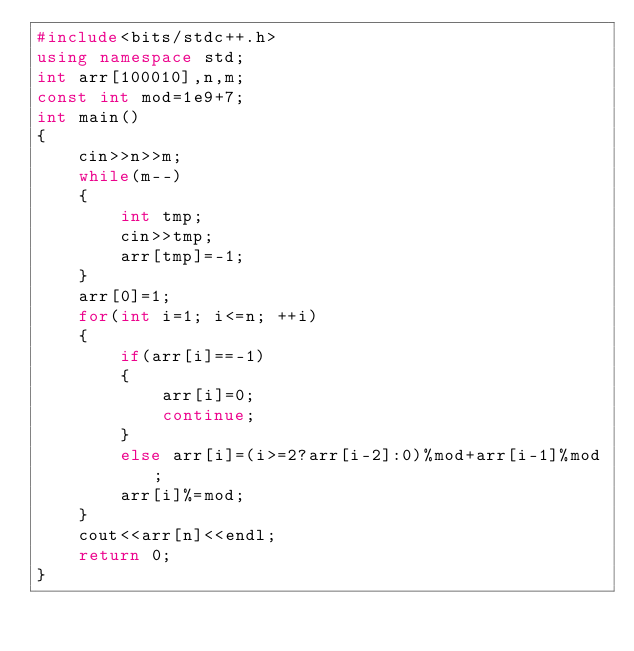<code> <loc_0><loc_0><loc_500><loc_500><_C++_>#include<bits/stdc++.h>
using namespace std;
int arr[100010],n,m;
const int mod=1e9+7;
int main()
{
    cin>>n>>m;
    while(m--)
    {
        int tmp;
        cin>>tmp;
        arr[tmp]=-1;
    }
    arr[0]=1;
    for(int i=1; i<=n; ++i)
    {
        if(arr[i]==-1)
        {
            arr[i]=0;
            continue;
        }
        else arr[i]=(i>=2?arr[i-2]:0)%mod+arr[i-1]%mod;
        arr[i]%=mod;
    }
    cout<<arr[n]<<endl;
    return 0;
}
</code> 